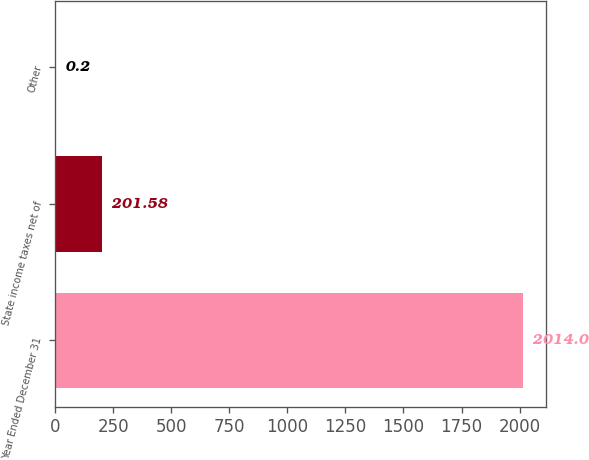Convert chart. <chart><loc_0><loc_0><loc_500><loc_500><bar_chart><fcel>Year Ended December 31<fcel>State income taxes net of<fcel>Other<nl><fcel>2014<fcel>201.58<fcel>0.2<nl></chart> 